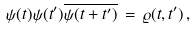Convert formula to latex. <formula><loc_0><loc_0><loc_500><loc_500>\psi ( { t } ) \psi ( { t } ^ { \prime } ) \overline { \psi ( { t } + { t } ^ { \prime } ) } \, = \, \varrho ( { t } , { t } ^ { \prime } ) \, ,</formula> 